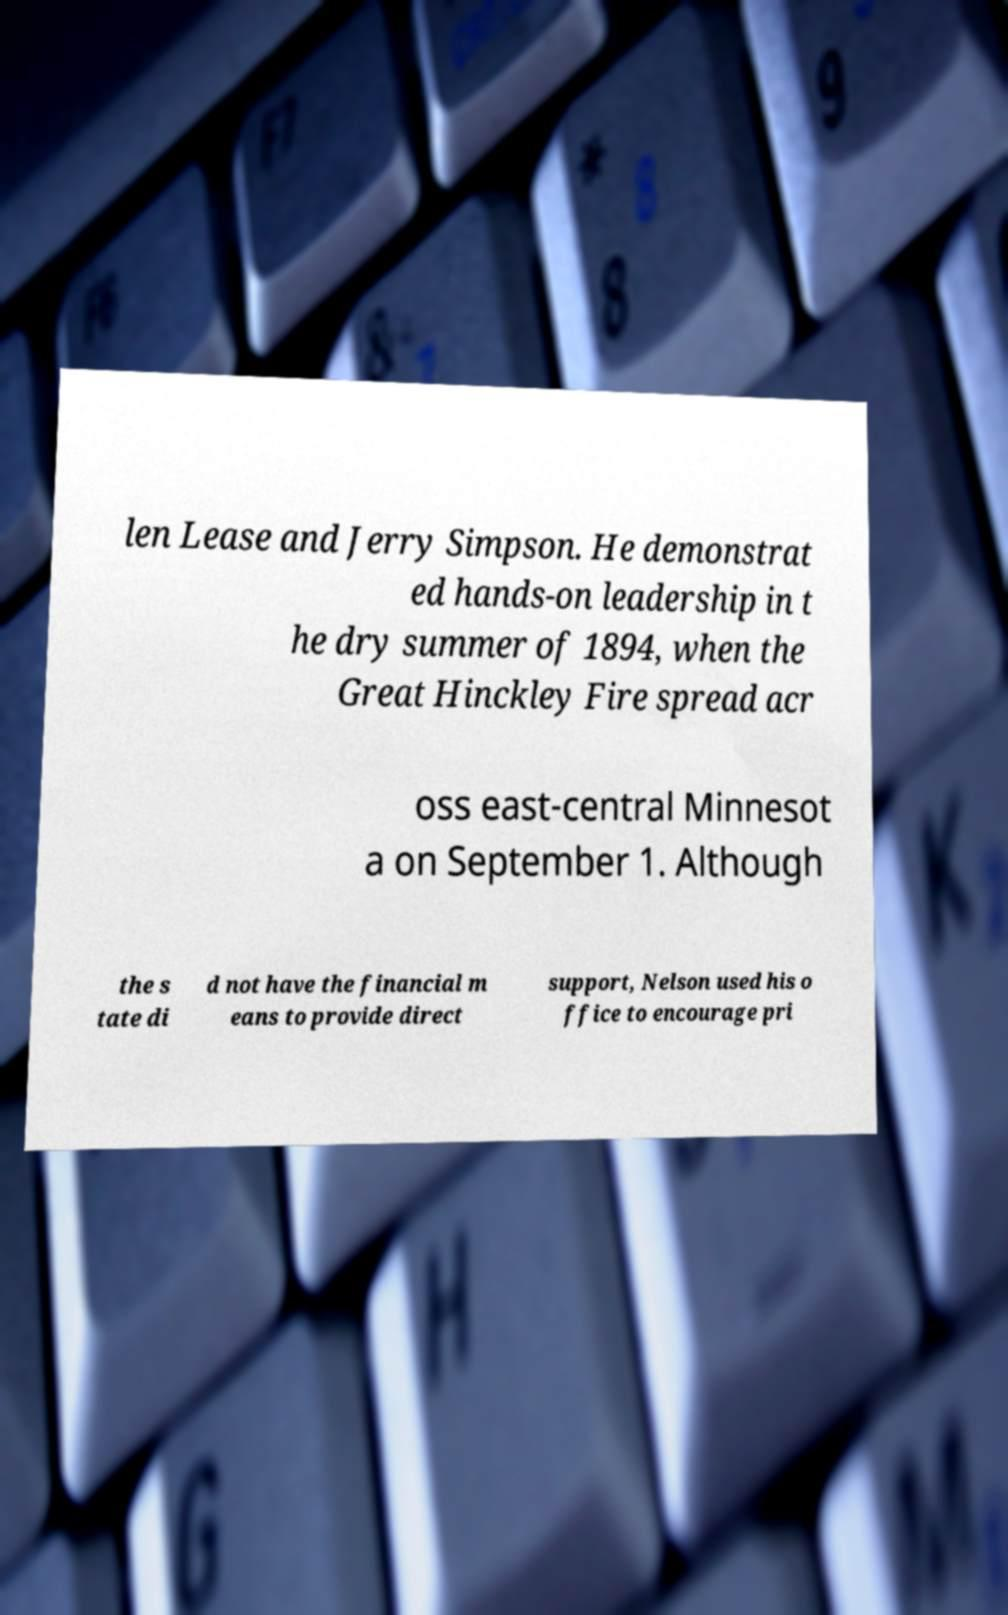What messages or text are displayed in this image? I need them in a readable, typed format. len Lease and Jerry Simpson. He demonstrat ed hands-on leadership in t he dry summer of 1894, when the Great Hinckley Fire spread acr oss east-central Minnesot a on September 1. Although the s tate di d not have the financial m eans to provide direct support, Nelson used his o ffice to encourage pri 